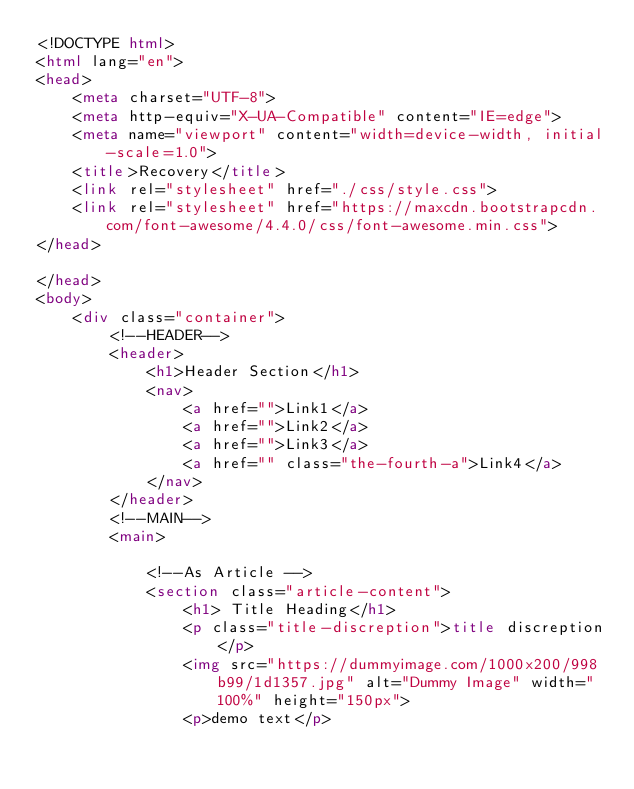<code> <loc_0><loc_0><loc_500><loc_500><_HTML_><!DOCTYPE html>
<html lang="en">
<head>
    <meta charset="UTF-8">
    <meta http-equiv="X-UA-Compatible" content="IE=edge">
    <meta name="viewport" content="width=device-width, initial-scale=1.0">
    <title>Recovery</title>
    <link rel="stylesheet" href="./css/style.css">
    <link rel="stylesheet" href="https://maxcdn.bootstrapcdn.com/font-awesome/4.4.0/css/font-awesome.min.css">
</head>
  
</head>
<body>
    <div class="container">
        <!--HEADER-->
        <header>
            <h1>Header Section</h1>
            <nav>
                <a href="">Link1</a>
                <a href="">Link2</a>
                <a href="">Link3</a>
                <a href="" class="the-fourth-a">Link4</a>
            </nav>
        </header>
        <!--MAIN-->
        <main>

            <!--As Article -->
            <section class="article-content">
                <h1> Title Heading</h1>
                <p class="title-discreption">title discreption</p>
                <img src="https://dummyimage.com/1000x200/998b99/1d1357.jpg" alt="Dummy Image" width="100%" height="150px">
                <p>demo text</p></code> 